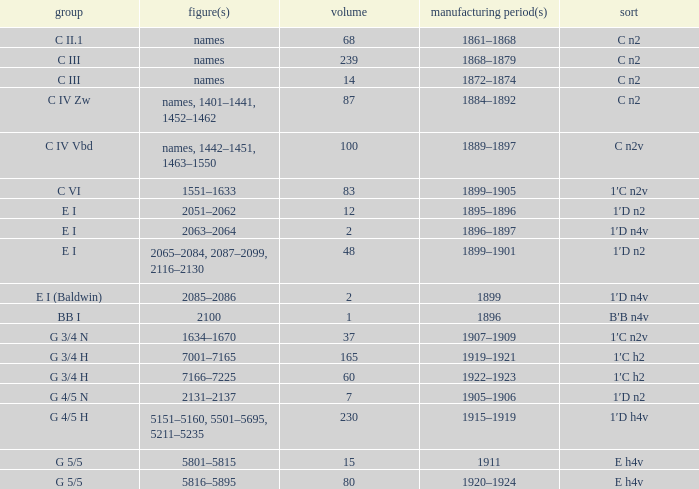Which Year(s) of Manufacture has a Quantity larger than 60, and a Number(s) of 7001–7165? 1919–1921. 